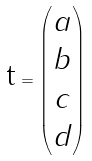<formula> <loc_0><loc_0><loc_500><loc_500>\text {t} = \begin{pmatrix} a \\ b \\ c \\ d \end{pmatrix}</formula> 